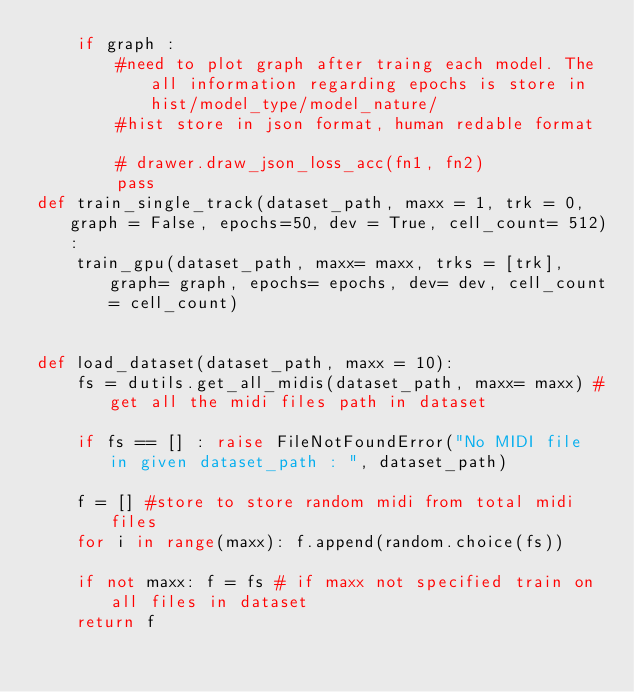Convert code to text. <code><loc_0><loc_0><loc_500><loc_500><_Python_>    if graph : 
        #need to plot graph after traing each model. The all information regarding epochs is store in hist/model_type/model_nature/
        #hist store in json format, human redable format
        
        # drawer.draw_json_loss_acc(fn1, fn2)
        pass
def train_single_track(dataset_path, maxx = 1, trk = 0, graph = False, epochs=50, dev = True, cell_count= 512):
    train_gpu(dataset_path, maxx= maxx, trks = [trk], graph= graph, epochs= epochs, dev= dev, cell_count= cell_count)


def load_dataset(dataset_path, maxx = 10):
    fs = dutils.get_all_midis(dataset_path, maxx= maxx) #get all the midi files path in dataset
    
    if fs == [] : raise FileNotFoundError("No MIDI file in given dataset_path : ", dataset_path)
    
    f = [] #store to store random midi from total midi files
    for i in range(maxx): f.append(random.choice(fs))

    if not maxx: f = fs # if maxx not specified train on all files in dataset
    return f
</code> 